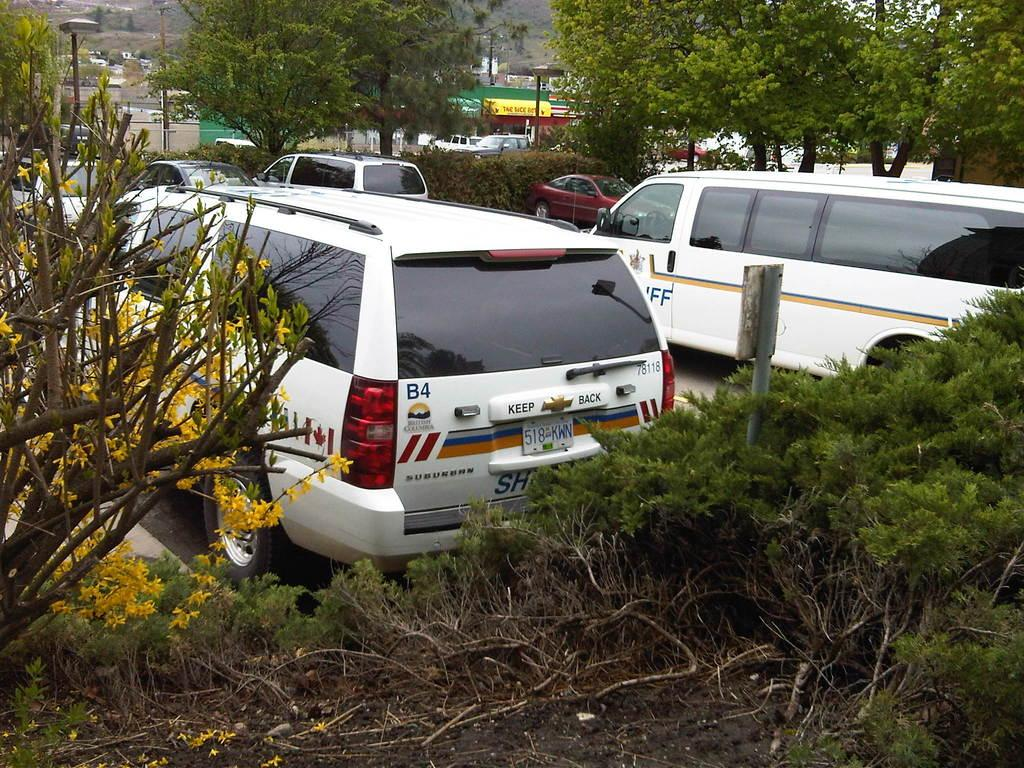What type of vehicles are present in the image? There are vans in the image. What color are the vans? The vans are white in color. What can be seen at the bottom of the image? There are plants at the bottom of the image. What type of flowers are near the plants? There are yellow flowers near the plants. What is visible in the background of the image? There are many trees in the background of the image. How does the queen feel about the thrill of the ticket in the image? There is no queen, thrill, or ticket present in the image. 